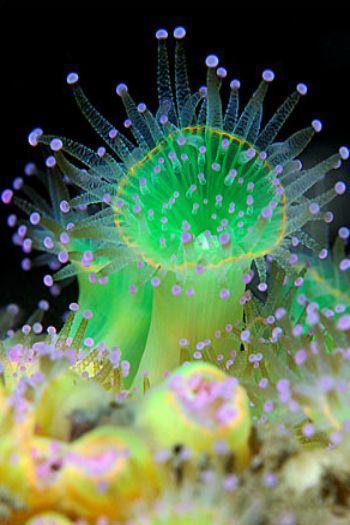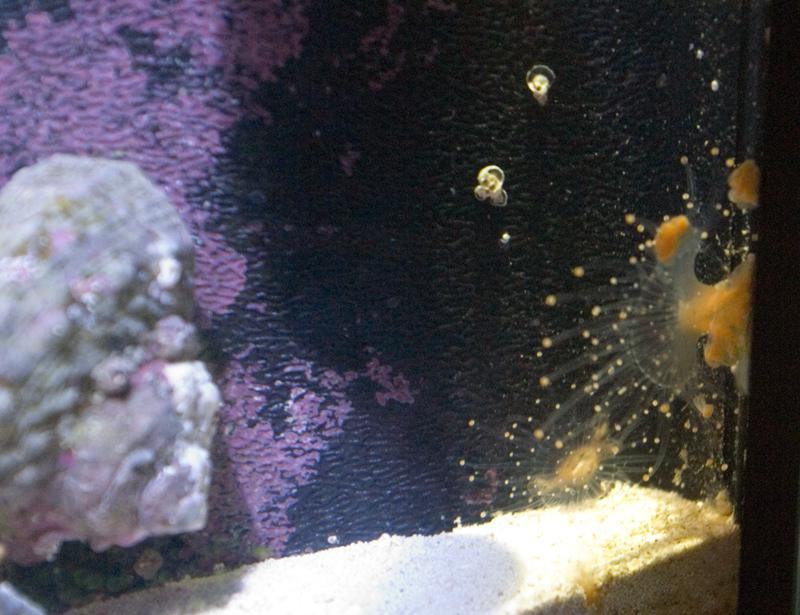The first image is the image on the left, the second image is the image on the right. For the images displayed, is the sentence "In the image to the left, the creature clearly has a green tint to it." factually correct? Answer yes or no. Yes. The first image is the image on the left, the second image is the image on the right. Considering the images on both sides, is "One image shows a mass of violet-colored anemones, and the other image shows a mass of anemone with orangish-coral color and visible white dots at the end of each tendril." valid? Answer yes or no. No. 